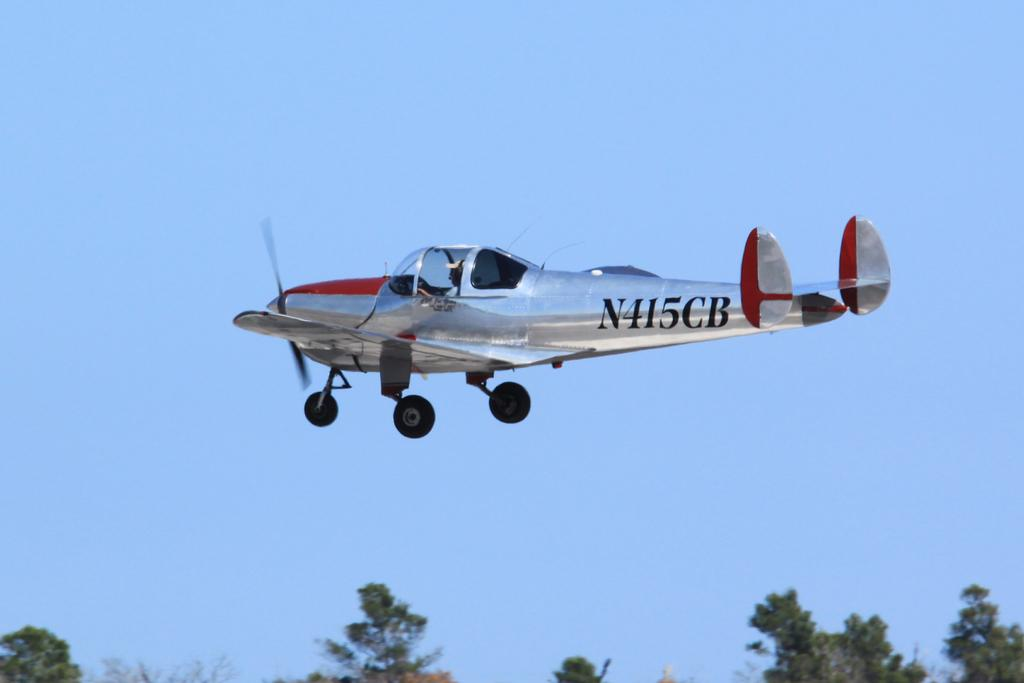What is the main subject of the image? The main subject of the image is an aeroplane. What is the aeroplane doing in the image? The aeroplane is flying in the sky. What can be seen at the bottom of the image? There are trees visible at the bottom of the image. How many cats are playing in the snow in the image? There are no cats or snow present in the image; it features an aeroplane flying in the sky with trees visible at the bottom. What type of destruction can be seen in the image? There is no destruction present in the image; it features an aeroplane flying in the sky with trees visible at the bottom. 